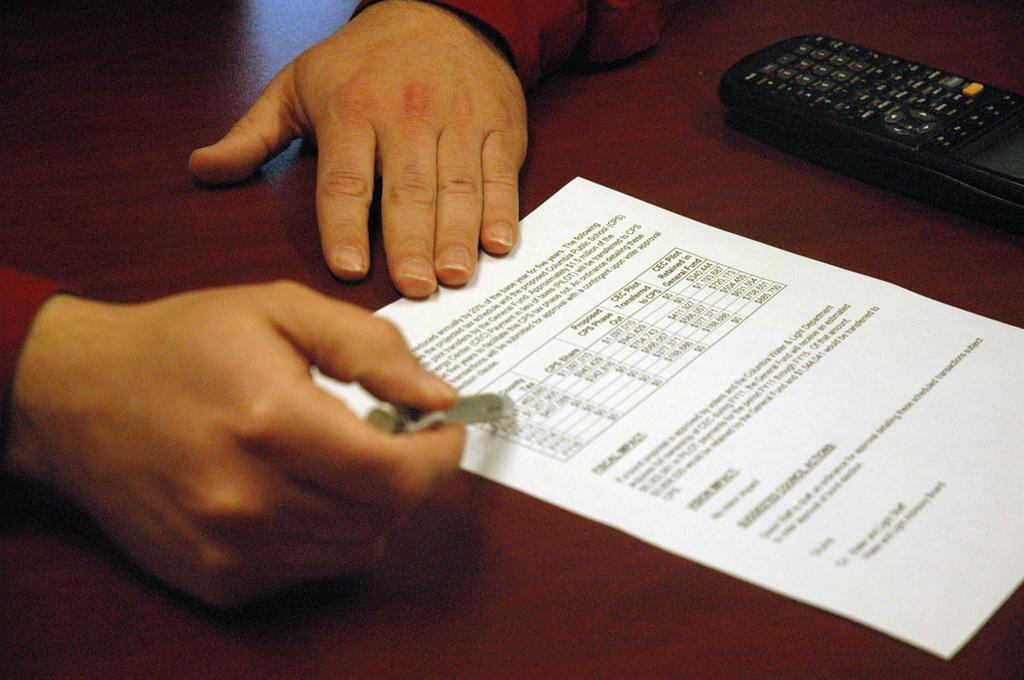What is present on the table in the image? There is a paper and a remote on the table in the image. What is written on the paper? There is text on the paper. What is the person on the left side of the image holding? The person is holding something in their hand. Can you describe the table in the image? The table is present in the image. What type of plastic material is being used for scientific experiments in the image? There is no plastic material or scientific experiments present in the image. How does the person transport themselves to the location of the image? The image does not provide information about how the person arrived at the location or any transportation methods. 